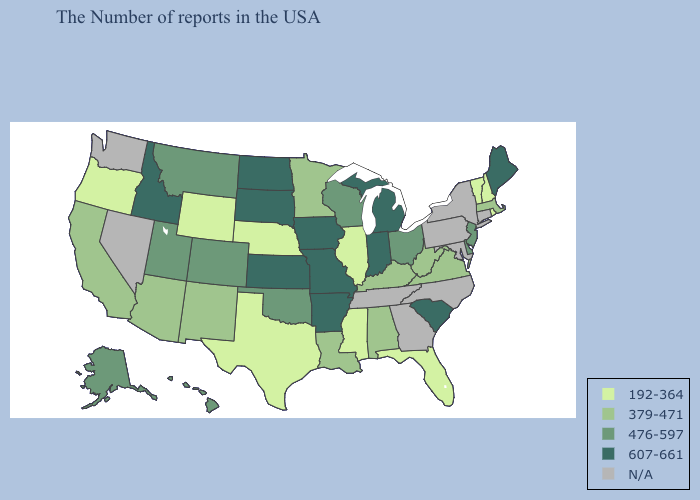Name the states that have a value in the range 476-597?
Quick response, please. New Jersey, Delaware, Ohio, Wisconsin, Oklahoma, Colorado, Utah, Montana, Alaska, Hawaii. Among the states that border Minnesota , does Iowa have the lowest value?
Be succinct. No. Does the first symbol in the legend represent the smallest category?
Concise answer only. Yes. What is the lowest value in states that border Kansas?
Quick response, please. 192-364. Name the states that have a value in the range 476-597?
Write a very short answer. New Jersey, Delaware, Ohio, Wisconsin, Oklahoma, Colorado, Utah, Montana, Alaska, Hawaii. What is the value of Washington?
Quick response, please. N/A. Does Idaho have the highest value in the West?
Short answer required. Yes. Does the map have missing data?
Concise answer only. Yes. Is the legend a continuous bar?
Be succinct. No. Name the states that have a value in the range N/A?
Give a very brief answer. Connecticut, New York, Maryland, Pennsylvania, North Carolina, Georgia, Tennessee, Nevada, Washington. Name the states that have a value in the range N/A?
Concise answer only. Connecticut, New York, Maryland, Pennsylvania, North Carolina, Georgia, Tennessee, Nevada, Washington. Does North Dakota have the highest value in the USA?
Short answer required. Yes. Which states have the highest value in the USA?
Write a very short answer. Maine, South Carolina, Michigan, Indiana, Missouri, Arkansas, Iowa, Kansas, South Dakota, North Dakota, Idaho. What is the highest value in the Northeast ?
Keep it brief. 607-661. 